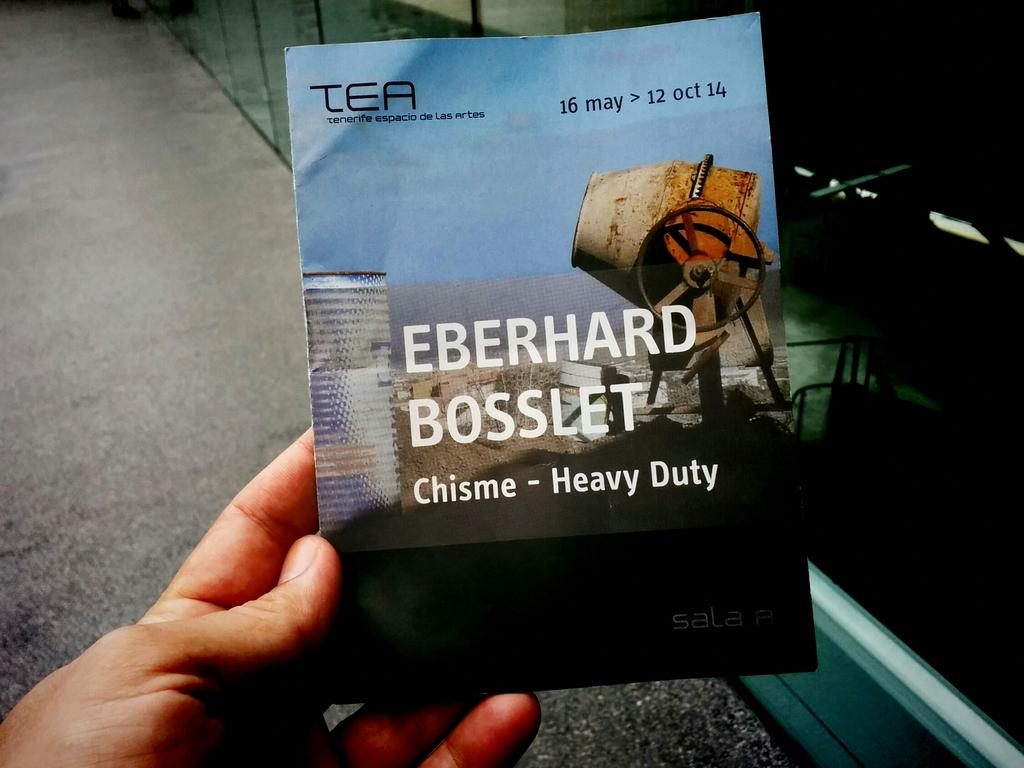<image>
Summarize the visual content of the image. A pamphlet with Heavy Duty written on the front cover. 